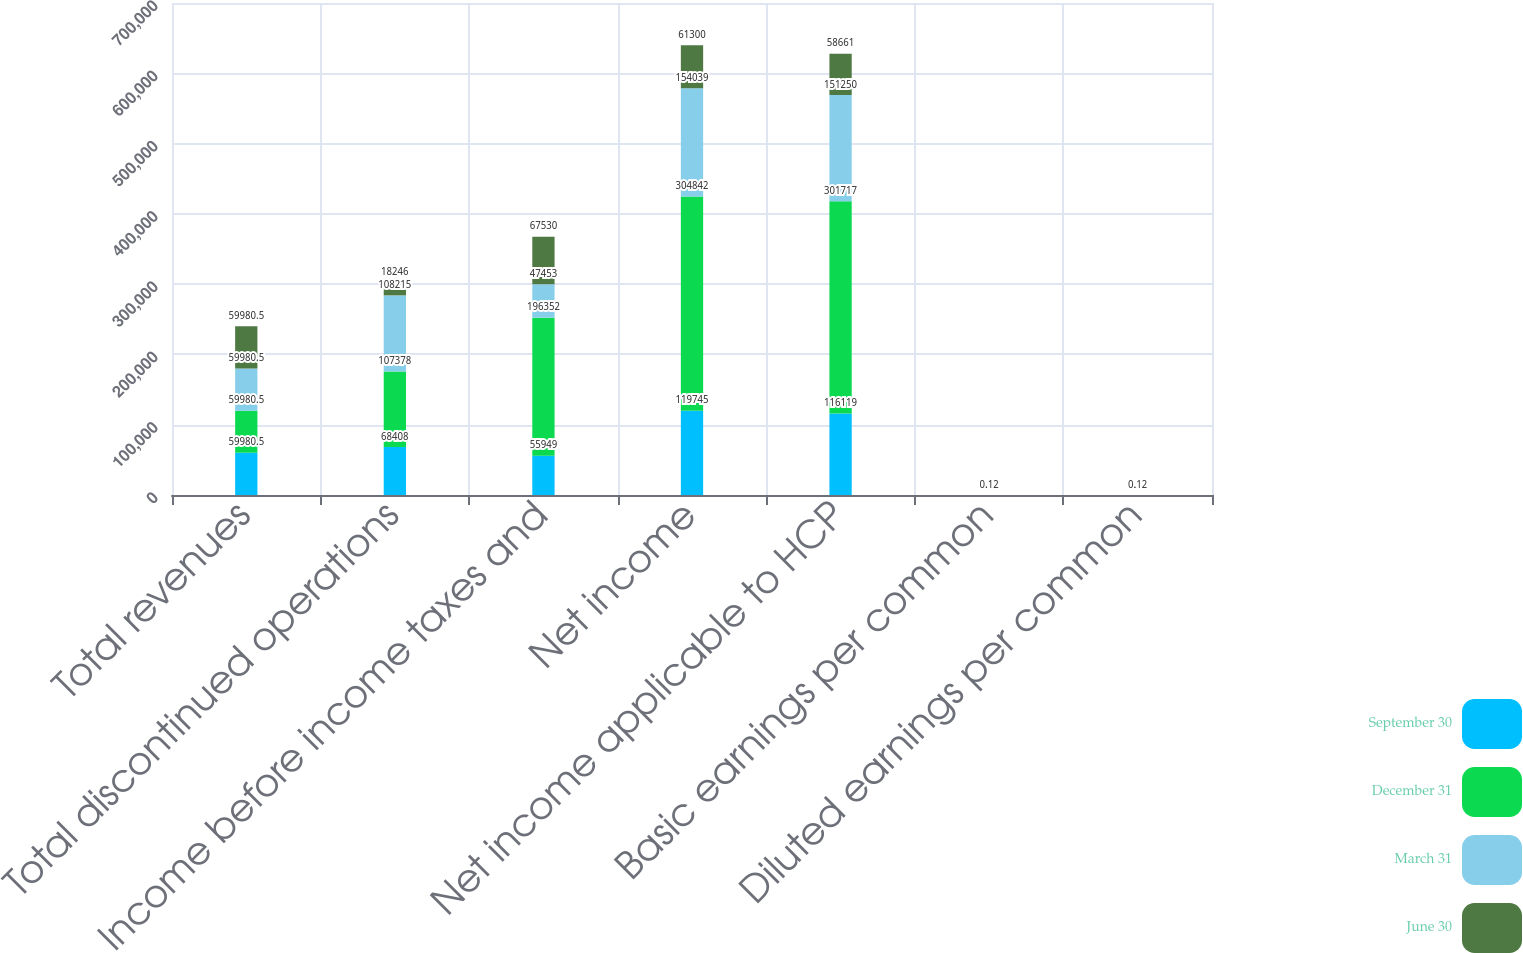<chart> <loc_0><loc_0><loc_500><loc_500><stacked_bar_chart><ecel><fcel>Total revenues<fcel>Total discontinued operations<fcel>Income before income taxes and<fcel>Net income<fcel>Net income applicable to HCP<fcel>Basic earnings per common<fcel>Diluted earnings per common<nl><fcel>September 30<fcel>59980.5<fcel>68408<fcel>55949<fcel>119745<fcel>116119<fcel>0.25<fcel>0.25<nl><fcel>December 31<fcel>59980.5<fcel>107378<fcel>196352<fcel>304842<fcel>301717<fcel>0.65<fcel>0.64<nl><fcel>March 31<fcel>59980.5<fcel>108215<fcel>47453<fcel>154039<fcel>151250<fcel>0.32<fcel>0.32<nl><fcel>June 30<fcel>59980.5<fcel>18246<fcel>67530<fcel>61300<fcel>58661<fcel>0.12<fcel>0.12<nl></chart> 